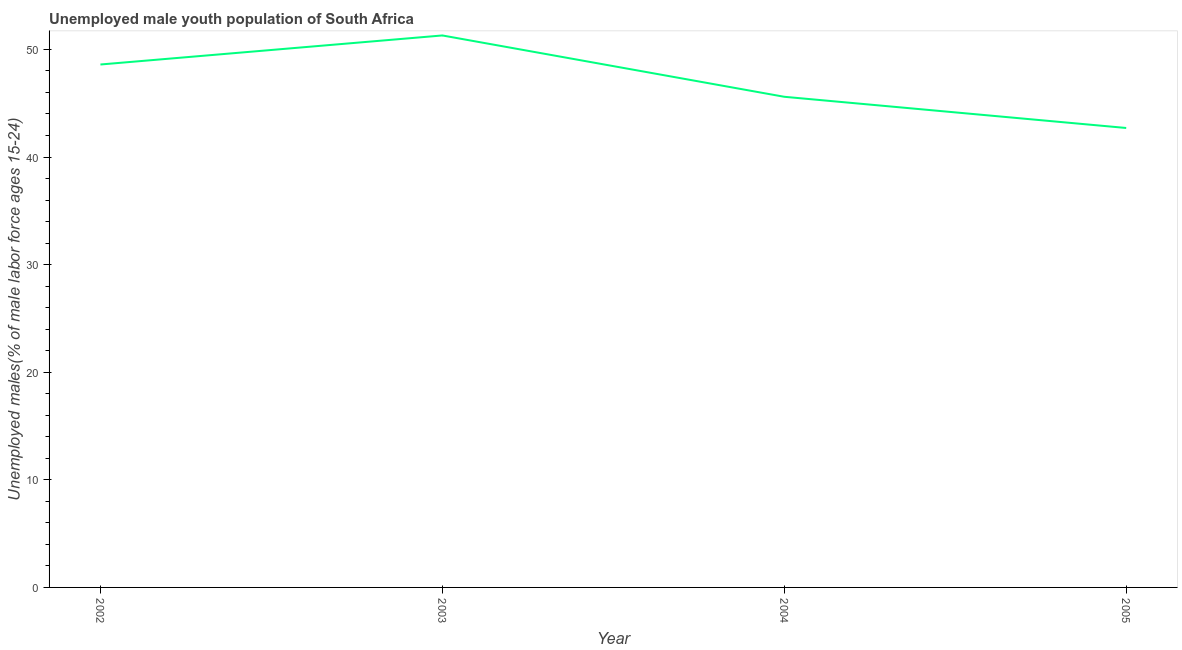What is the unemployed male youth in 2003?
Give a very brief answer. 51.3. Across all years, what is the maximum unemployed male youth?
Provide a succinct answer. 51.3. Across all years, what is the minimum unemployed male youth?
Your response must be concise. 42.7. In which year was the unemployed male youth maximum?
Provide a short and direct response. 2003. In which year was the unemployed male youth minimum?
Offer a terse response. 2005. What is the sum of the unemployed male youth?
Ensure brevity in your answer.  188.2. What is the difference between the unemployed male youth in 2002 and 2005?
Provide a short and direct response. 5.9. What is the average unemployed male youth per year?
Provide a short and direct response. 47.05. What is the median unemployed male youth?
Give a very brief answer. 47.1. What is the ratio of the unemployed male youth in 2003 to that in 2004?
Provide a succinct answer. 1.13. Is the difference between the unemployed male youth in 2003 and 2004 greater than the difference between any two years?
Offer a terse response. No. What is the difference between the highest and the second highest unemployed male youth?
Ensure brevity in your answer.  2.7. Is the sum of the unemployed male youth in 2003 and 2004 greater than the maximum unemployed male youth across all years?
Offer a very short reply. Yes. What is the difference between the highest and the lowest unemployed male youth?
Your answer should be compact. 8.6. In how many years, is the unemployed male youth greater than the average unemployed male youth taken over all years?
Offer a terse response. 2. Does the unemployed male youth monotonically increase over the years?
Ensure brevity in your answer.  No. What is the difference between two consecutive major ticks on the Y-axis?
Your answer should be compact. 10. Are the values on the major ticks of Y-axis written in scientific E-notation?
Give a very brief answer. No. Does the graph contain any zero values?
Provide a short and direct response. No. What is the title of the graph?
Your response must be concise. Unemployed male youth population of South Africa. What is the label or title of the X-axis?
Offer a very short reply. Year. What is the label or title of the Y-axis?
Offer a very short reply. Unemployed males(% of male labor force ages 15-24). What is the Unemployed males(% of male labor force ages 15-24) of 2002?
Keep it short and to the point. 48.6. What is the Unemployed males(% of male labor force ages 15-24) in 2003?
Offer a terse response. 51.3. What is the Unemployed males(% of male labor force ages 15-24) in 2004?
Keep it short and to the point. 45.6. What is the Unemployed males(% of male labor force ages 15-24) in 2005?
Ensure brevity in your answer.  42.7. What is the difference between the Unemployed males(% of male labor force ages 15-24) in 2003 and 2005?
Make the answer very short. 8.6. What is the ratio of the Unemployed males(% of male labor force ages 15-24) in 2002 to that in 2003?
Keep it short and to the point. 0.95. What is the ratio of the Unemployed males(% of male labor force ages 15-24) in 2002 to that in 2004?
Your response must be concise. 1.07. What is the ratio of the Unemployed males(% of male labor force ages 15-24) in 2002 to that in 2005?
Keep it short and to the point. 1.14. What is the ratio of the Unemployed males(% of male labor force ages 15-24) in 2003 to that in 2004?
Give a very brief answer. 1.12. What is the ratio of the Unemployed males(% of male labor force ages 15-24) in 2003 to that in 2005?
Make the answer very short. 1.2. What is the ratio of the Unemployed males(% of male labor force ages 15-24) in 2004 to that in 2005?
Offer a terse response. 1.07. 